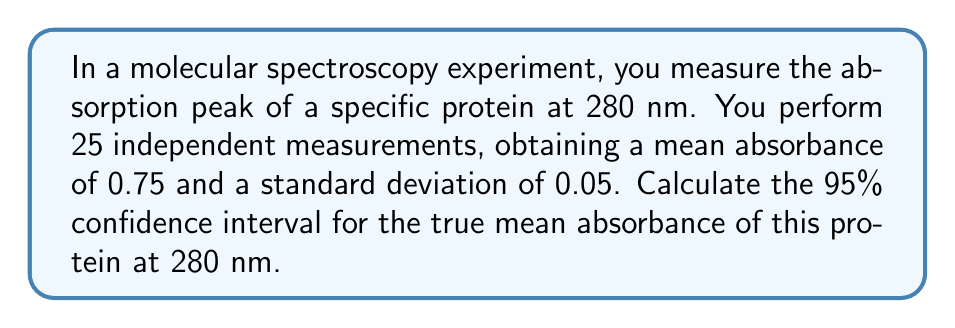Help me with this question. To calculate the confidence interval, we'll follow these steps:

1. Identify the known values:
   - Sample size: $n = 25$
   - Sample mean: $\bar{x} = 0.75$
   - Sample standard deviation: $s = 0.05$
   - Confidence level: 95% (α = 0.05)

2. Determine the critical value:
   For a 95% confidence interval with 24 degrees of freedom (n-1), we use the t-distribution. The critical value is $t_{0.025, 24} = 2.064$ (from t-distribution table).

3. Calculate the standard error of the mean:
   $SE_{\bar{x}} = \frac{s}{\sqrt{n}} = \frac{0.05}{\sqrt{25}} = 0.01$

4. Compute the margin of error:
   $E = t_{0.025, 24} \cdot SE_{\bar{x}} = 2.064 \cdot 0.01 = 0.02064$

5. Calculate the confidence interval:
   Lower bound: $\bar{x} - E = 0.75 - 0.02064 = 0.72936$
   Upper bound: $\bar{x} + E = 0.75 + 0.02064 = 0.77064$

Thus, the 95% confidence interval is (0.72936, 0.77064).
Answer: (0.72936, 0.77064) 